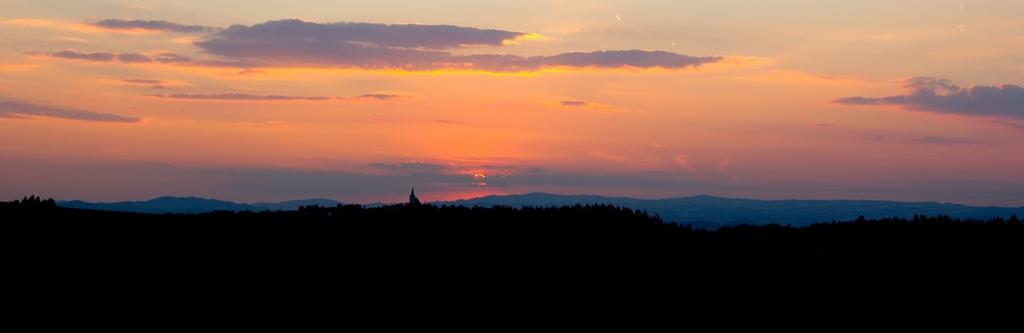What type of natural formation can be seen in the image? The image contains mountains. What covers the mountains in the image? The mountains are covered with trees. What part of the sky is visible in the image? The sky is visible in the image. What is the color of the sky in the image? The sky has a red color in the image. What celestial body is present in the image? There is a sun in the image. What else can be seen in the sky in the image? Clouds are present in the image. Where is the kettle located in the image? There is no kettle present in the image. What type of shop can be seen in the image? There is no shop present in the image. 